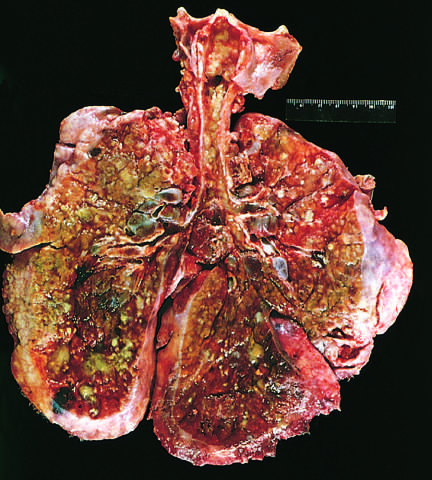what is the pulmonary parenchyma consolidated by?
Answer the question using a single word or phrase. The combination of both secretions and pneumonia 